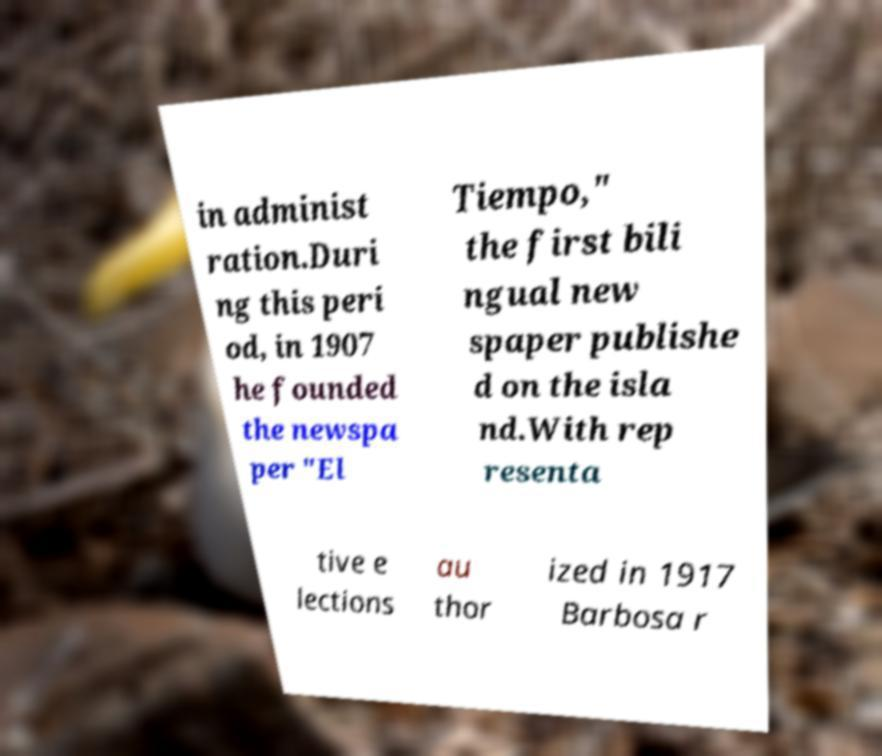Please read and relay the text visible in this image. What does it say? in administ ration.Duri ng this peri od, in 1907 he founded the newspa per "El Tiempo," the first bili ngual new spaper publishe d on the isla nd.With rep resenta tive e lections au thor ized in 1917 Barbosa r 